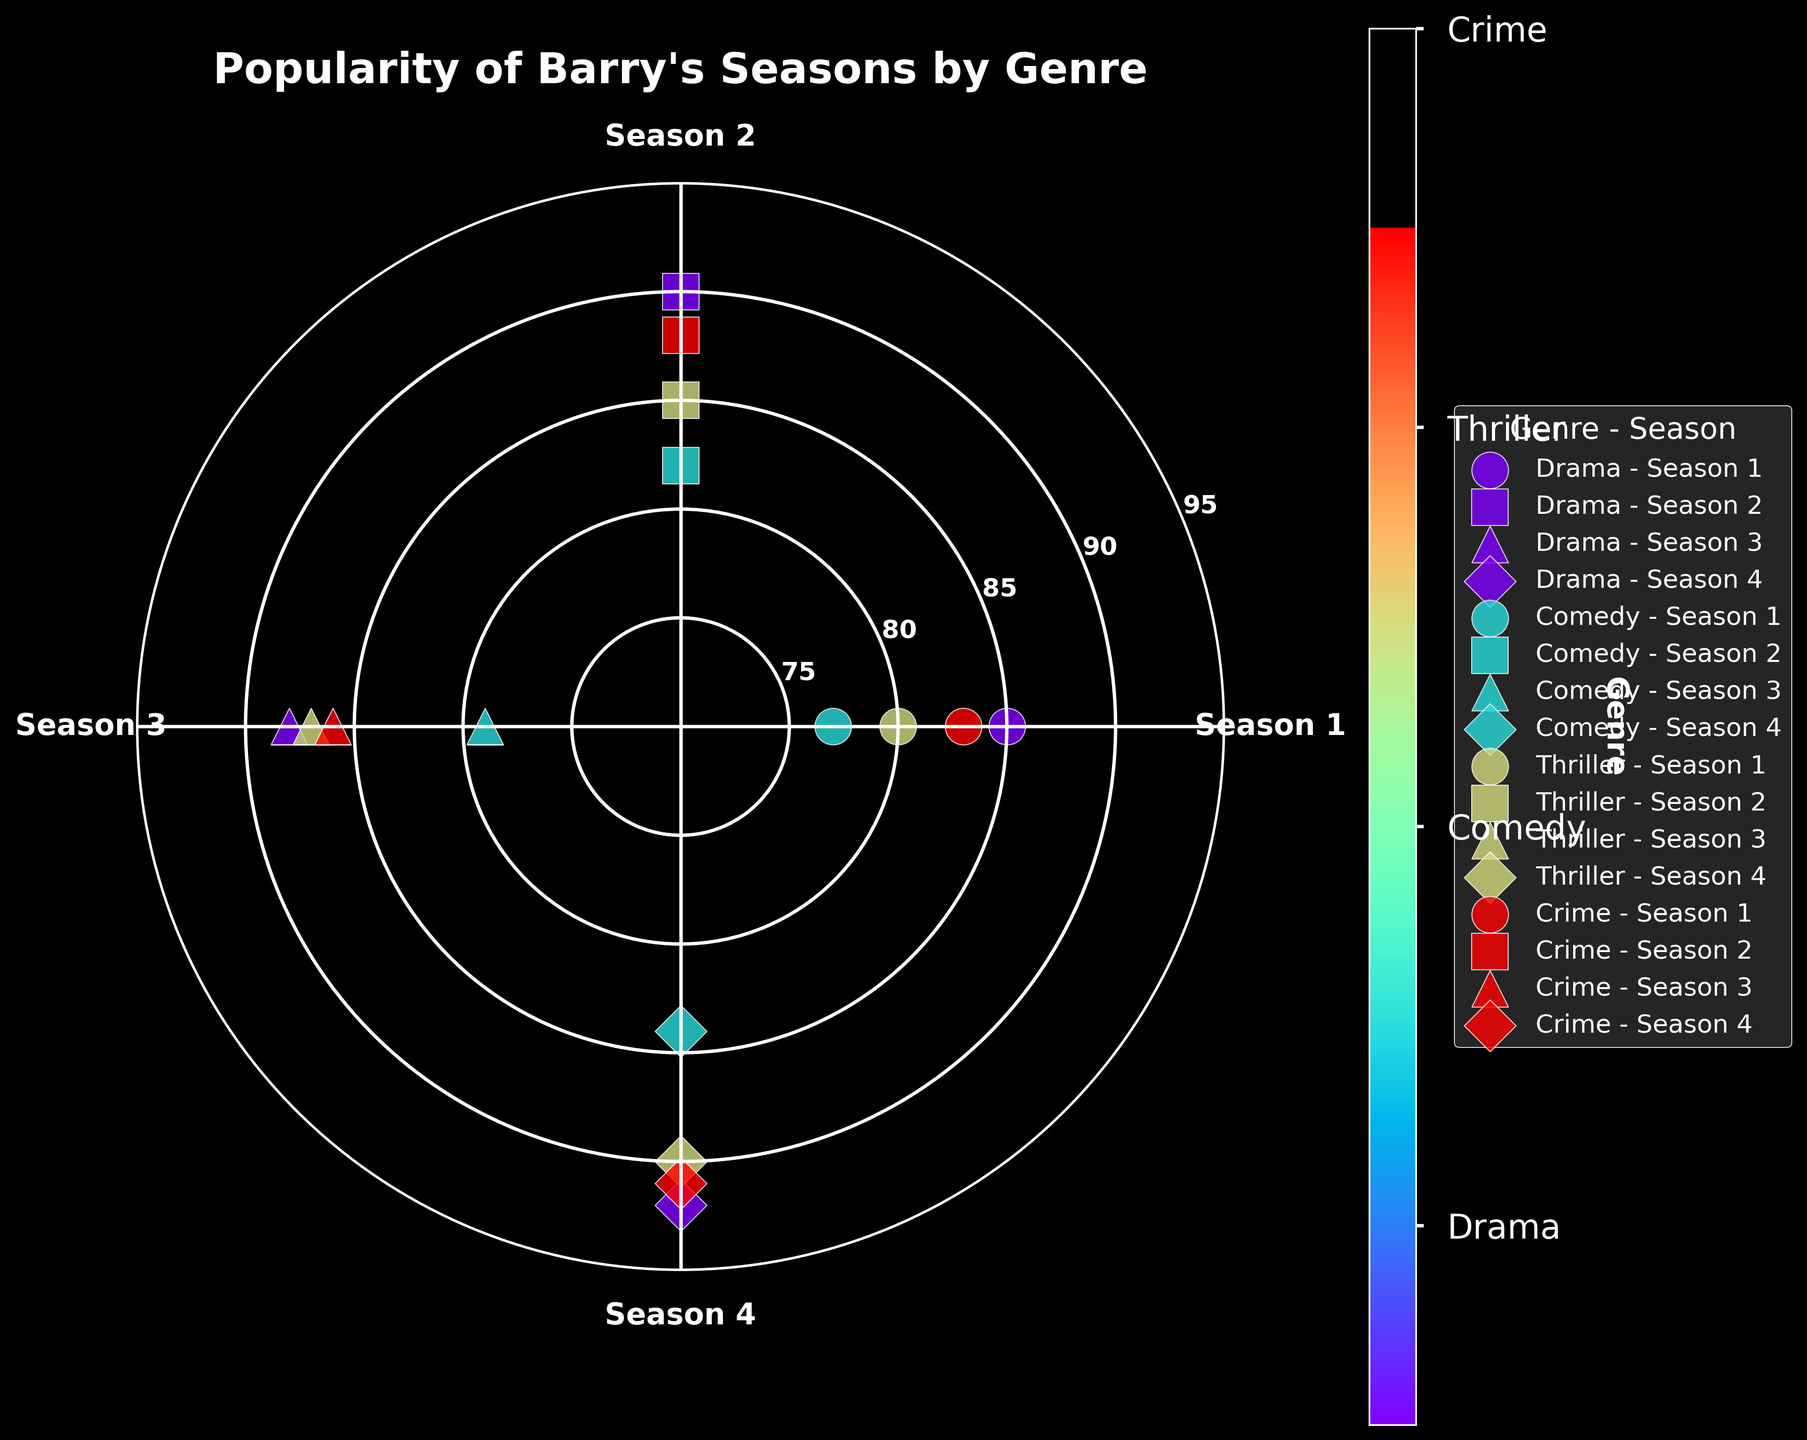What is the highest popularity rating for the Drama genre? Starting with the "Drama" genre, we look for the highest rating among its seasons. The ratings are 85, 90, 88, and 92. The maximum rating here is 92.
Answer: 92 Which season of the Comedy genre has the highest popularity? Examining the popularity for "Comedy" across all seasons: Season 1 (77), Season 2 (82), Season 3 (79), and Season 4 (84). Season 4 has the highest rating at 84.
Answer: Season 4 What is the average popularity of Season 2 across all genres? For Season 2, the ratings are: Drama (90), Comedy (82), Thriller (85), and Crime (88). Summing these gives 90 + 82 + 85 + 88 = 345. Dividing by 4 (number of genres), we get 345 / 4 = 86.25.
Answer: 86.25 Which genre has the lowest minimum popularity rating? Comparing the minimum popularity ratings across genres: Drama (85), Comedy (77), Thriller (80), and Crime (83). Comedy has the lowest minimum rating of 77.
Answer: Comedy How much more popular is Thriller in Season 4 compared to Season 1? Thriller's popularity in Season 4 is 90, and in Season 1 is 80. So, the difference is 90 - 80 = 10.
Answer: 10 Which season shows the highest increase in popularity for the Crime genre? Popularity in Crime shows: Season 1 (83), Season 2 (88), Season 3 (86), and Season 4 (91). Season 1 to Season 2 increases by 88 - 83 = 5, Season 2 to Season 3 decreases, and Season 3 to Season 4 increases by 91 - 86 = 5. Therefore, both Season 1 to 2 and Season 3 to 4 show the highest increase of 5.
Answer: Season 1 to 2 and Season 3 to 4 